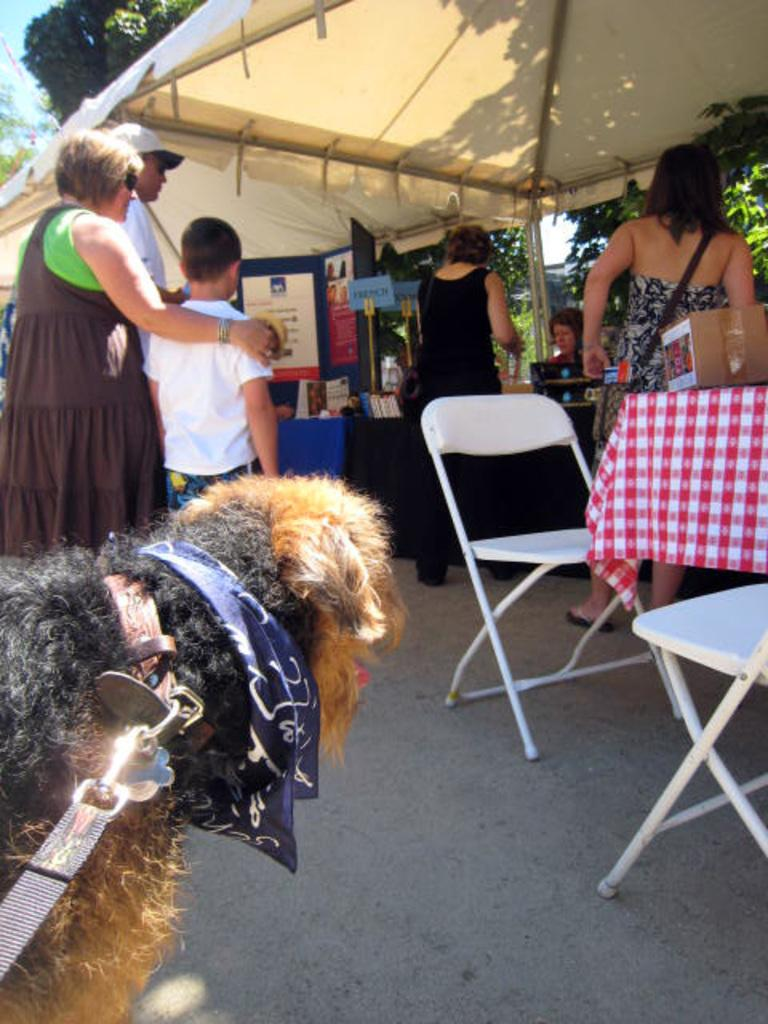What color is the cloth that is visible in the image? There is a cream-colored cloth in the image. Who or what can be seen in the image besides the cloth? There are people, a tree, a poster, chairs, and a dog in the image. Where is the tree located in the image? The tree is in the image. What is the purpose of the poster in the image? The purpose of the poster is not specified in the facts, but it is present in the image. How many chairs are visible in the image? There are chairs in the image. What type of instrument is the dog playing in the image? There is no instrument present in the image, and the dog is not playing any instrument. 